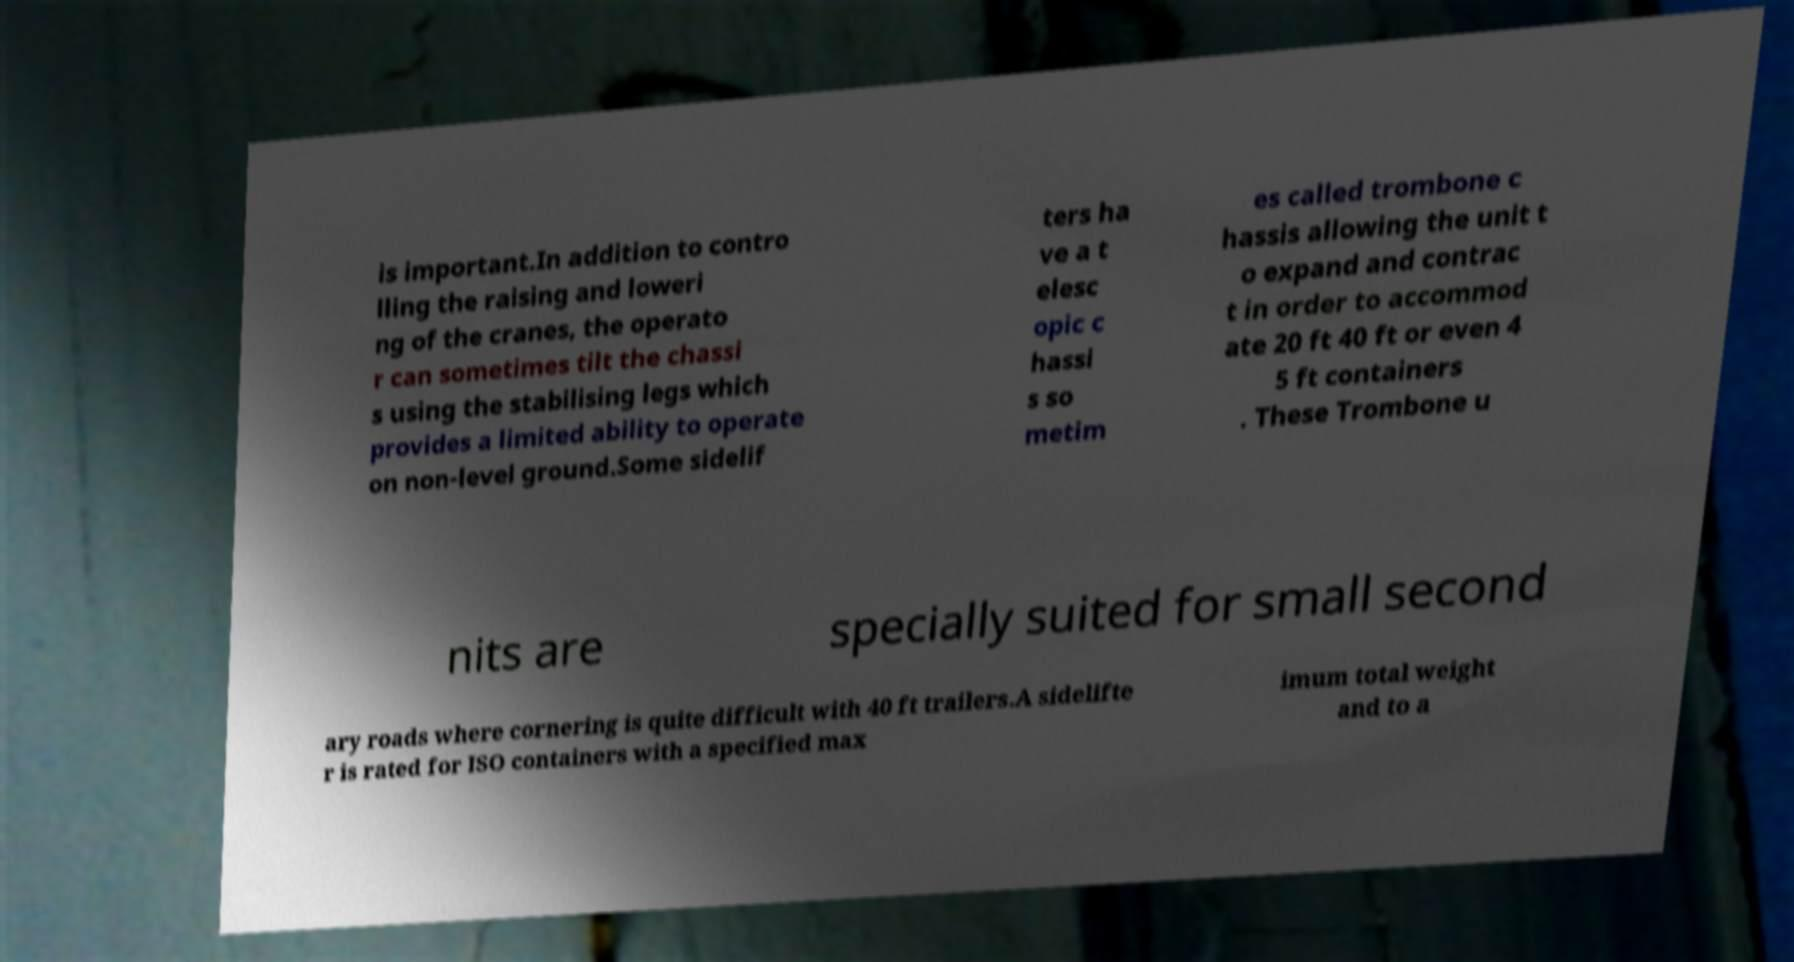For documentation purposes, I need the text within this image transcribed. Could you provide that? is important.In addition to contro lling the raising and loweri ng of the cranes, the operato r can sometimes tilt the chassi s using the stabilising legs which provides a limited ability to operate on non-level ground.Some sidelif ters ha ve a t elesc opic c hassi s so metim es called trombone c hassis allowing the unit t o expand and contrac t in order to accommod ate 20 ft 40 ft or even 4 5 ft containers . These Trombone u nits are specially suited for small second ary roads where cornering is quite difficult with 40 ft trailers.A sidelifte r is rated for ISO containers with a specified max imum total weight and to a 